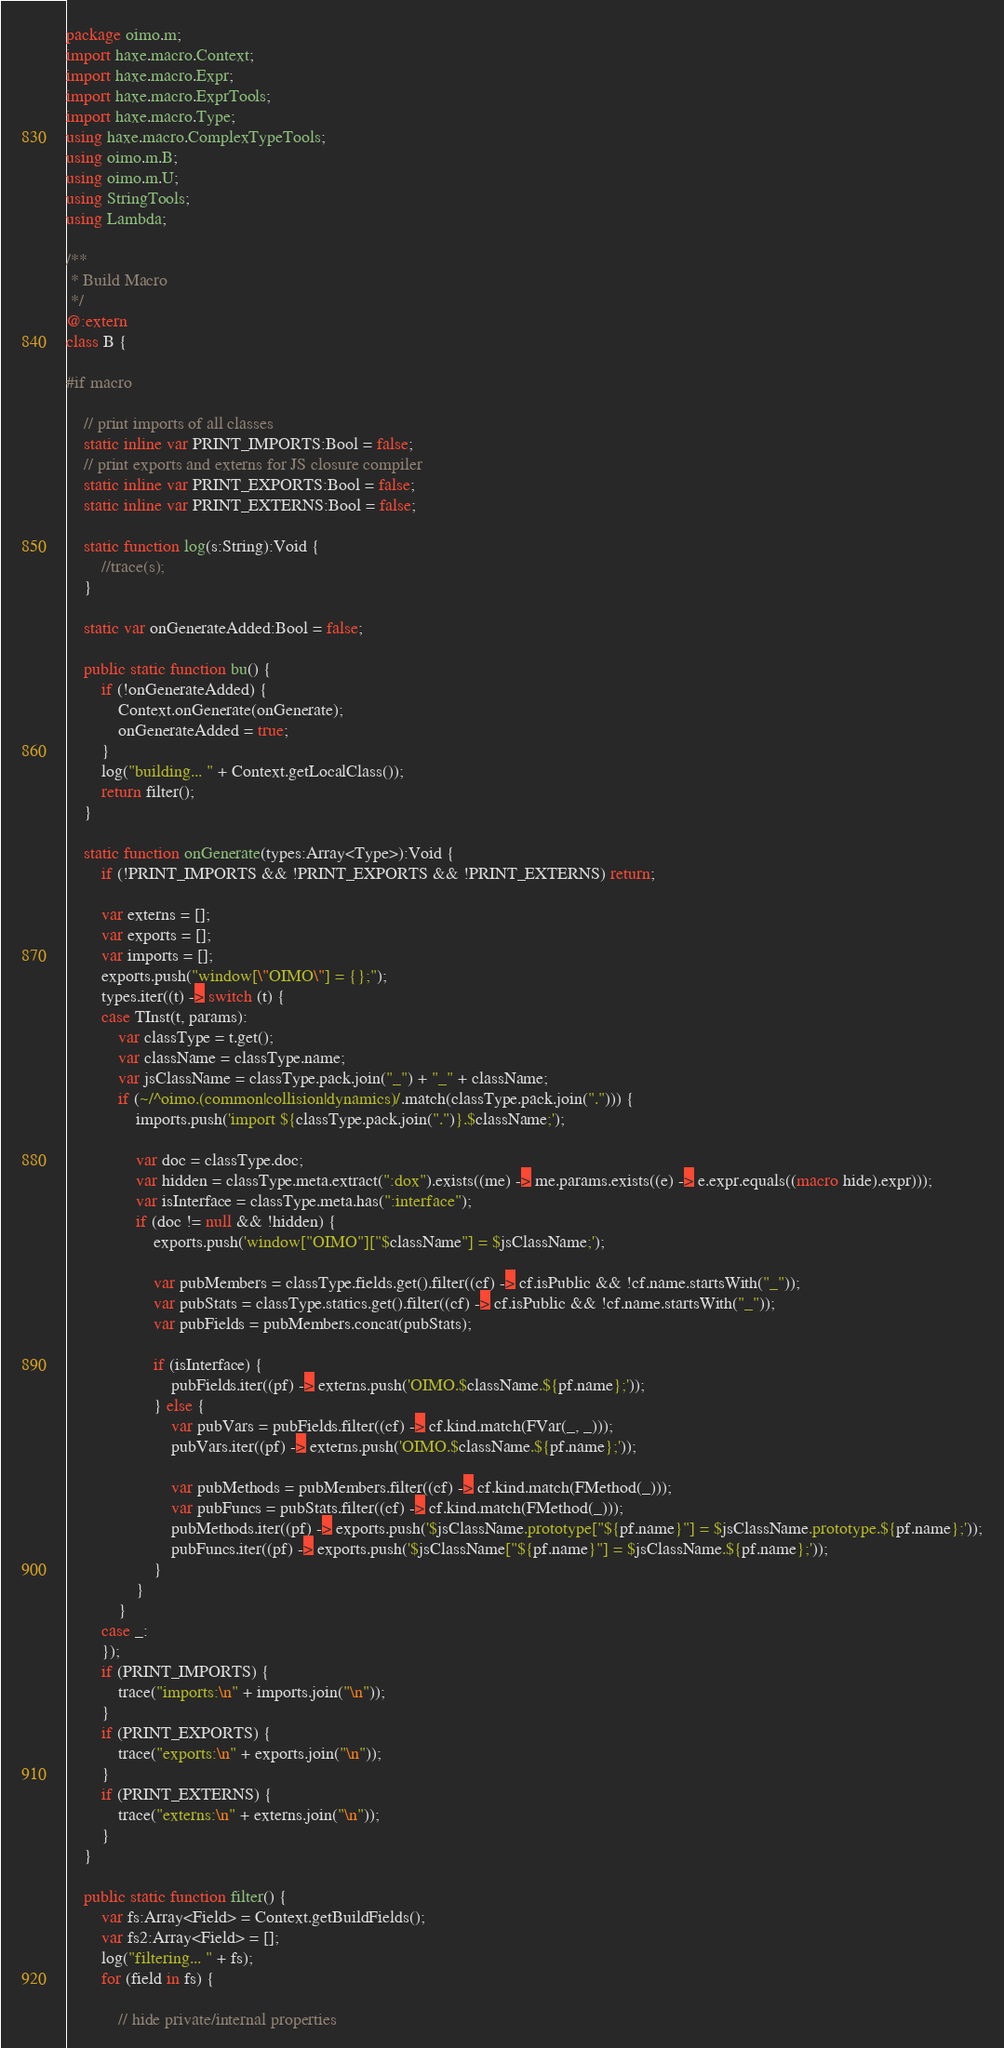Convert code to text. <code><loc_0><loc_0><loc_500><loc_500><_Haxe_>package oimo.m;
import haxe.macro.Context;
import haxe.macro.Expr;
import haxe.macro.ExprTools;
import haxe.macro.Type;
using haxe.macro.ComplexTypeTools;
using oimo.m.B;
using oimo.m.U;
using StringTools;
using Lambda;

/**
 * Build Macro
 */
@:extern
class B {

#if macro

	// print imports of all classes
	static inline var PRINT_IMPORTS:Bool = false;
	// print exports and externs for JS closure compiler
	static inline var PRINT_EXPORTS:Bool = false;
	static inline var PRINT_EXTERNS:Bool = false;

	static function log(s:String):Void {
		//trace(s);
	}

	static var onGenerateAdded:Bool = false;

	public static function bu() {
		if (!onGenerateAdded) {
			Context.onGenerate(onGenerate);
			onGenerateAdded = true;
		}
		log("building... " + Context.getLocalClass());
		return filter();
	}

	static function onGenerate(types:Array<Type>):Void {
		if (!PRINT_IMPORTS && !PRINT_EXPORTS && !PRINT_EXTERNS) return;

		var externs = [];
		var exports = [];
		var imports = [];
		exports.push("window[\"OIMO\"] = {};");
		types.iter((t) -> switch (t) {
		case TInst(t, params):
			var classType = t.get();
			var className = classType.name;
			var jsClassName = classType.pack.join("_") + "_" + className;
			if (~/^oimo.(common|collision|dynamics)/.match(classType.pack.join("."))) {
				imports.push('import ${classType.pack.join(".")}.$className;');

				var doc = classType.doc;
				var hidden = classType.meta.extract(":dox").exists((me) -> me.params.exists((e) -> e.expr.equals((macro hide).expr)));
				var isInterface = classType.meta.has(":interface");
				if (doc != null && !hidden) {
					exports.push('window["OIMO"]["$className"] = $jsClassName;');

					var pubMembers = classType.fields.get().filter((cf) -> cf.isPublic && !cf.name.startsWith("_"));
					var pubStats = classType.statics.get().filter((cf) -> cf.isPublic && !cf.name.startsWith("_"));
					var pubFields = pubMembers.concat(pubStats);

					if (isInterface) {
						pubFields.iter((pf) -> externs.push('OIMO.$className.${pf.name};'));
					} else {
						var pubVars = pubFields.filter((cf) -> cf.kind.match(FVar(_, _)));
						pubVars.iter((pf) -> externs.push('OIMO.$className.${pf.name};'));

						var pubMethods = pubMembers.filter((cf) -> cf.kind.match(FMethod(_)));
						var pubFuncs = pubStats.filter((cf) -> cf.kind.match(FMethod(_)));
						pubMethods.iter((pf) -> exports.push('$jsClassName.prototype["${pf.name}"] = $jsClassName.prototype.${pf.name};'));
						pubFuncs.iter((pf) -> exports.push('$jsClassName["${pf.name}"] = $jsClassName.${pf.name};'));
					}
				}
			}
		case _:
		});
		if (PRINT_IMPORTS) {
			trace("imports:\n" + imports.join("\n"));
		}
		if (PRINT_EXPORTS) {
			trace("exports:\n" + exports.join("\n"));
		}
		if (PRINT_EXTERNS) {
			trace("externs:\n" + externs.join("\n"));
		}
	}

	public static function filter() {
		var fs:Array<Field> = Context.getBuildFields();
		var fs2:Array<Field> = [];
		log("filtering... " + fs);
		for (field in fs) {

			// hide private/internal properties</code> 